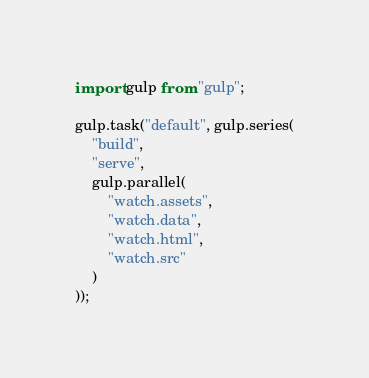<code> <loc_0><loc_0><loc_500><loc_500><_JavaScript_>import gulp from "gulp";

gulp.task("default", gulp.series(
    "build",
    "serve",
    gulp.parallel(
        "watch.assets",
        "watch.data",
        "watch.html",
        "watch.src"
    )
));
</code> 